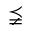<formula> <loc_0><loc_0><loc_500><loc_500>\precneqq</formula> 